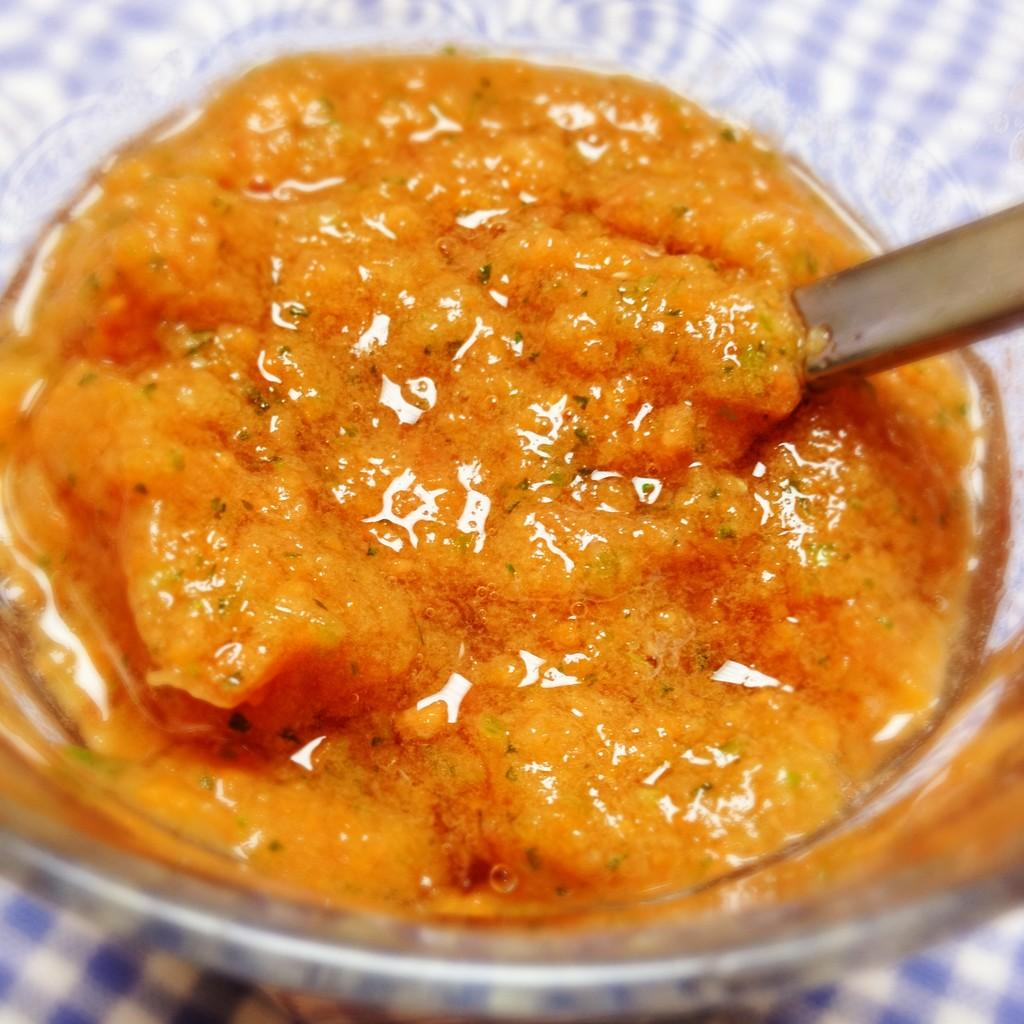What is located in the center of the image? There is a table in the center of the image. What is covering the table? There is a cloth on the table. What is placed on top of the cloth? There is a bowl on the table. What is inside the bowl? There are food items in the bowl. What utensil is used to eat the food in the bowl? There is a spoon in the bowl. Can you tell me how many fingers are pushing the bowl in the image? There are no fingers or pushing action depicted in the image; it only shows a table with a cloth, bowl, spoon, and food items. 